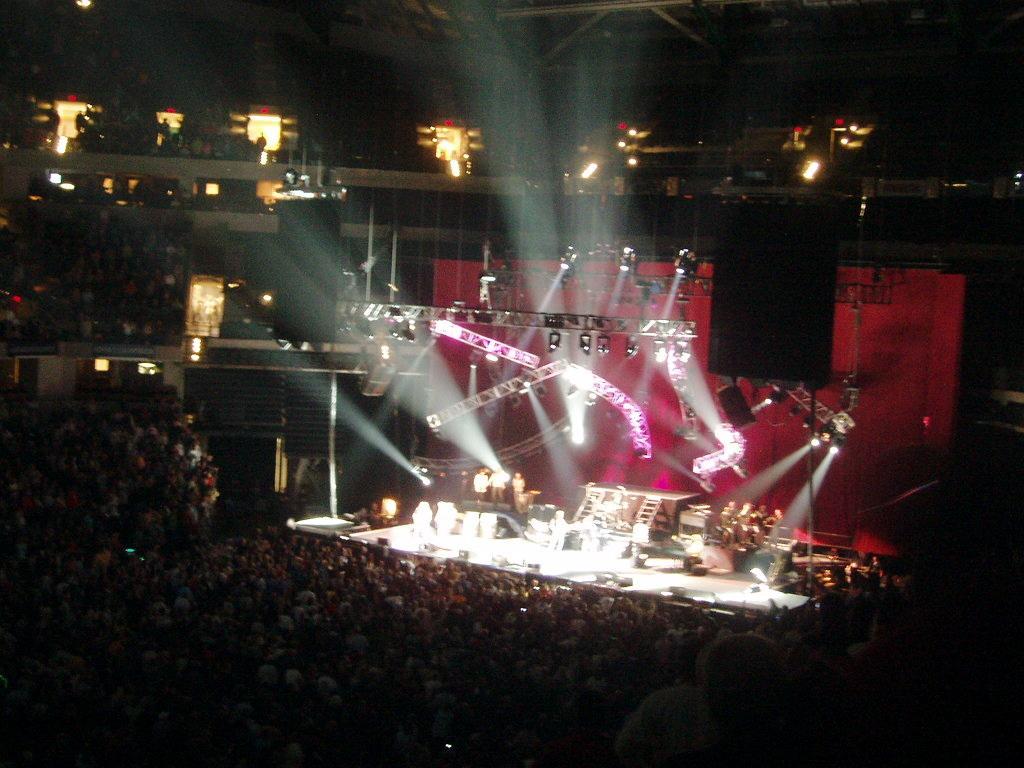Please provide a concise description of this image. As we can see in the image there are group of people here and there and lights. The image is little dark. 